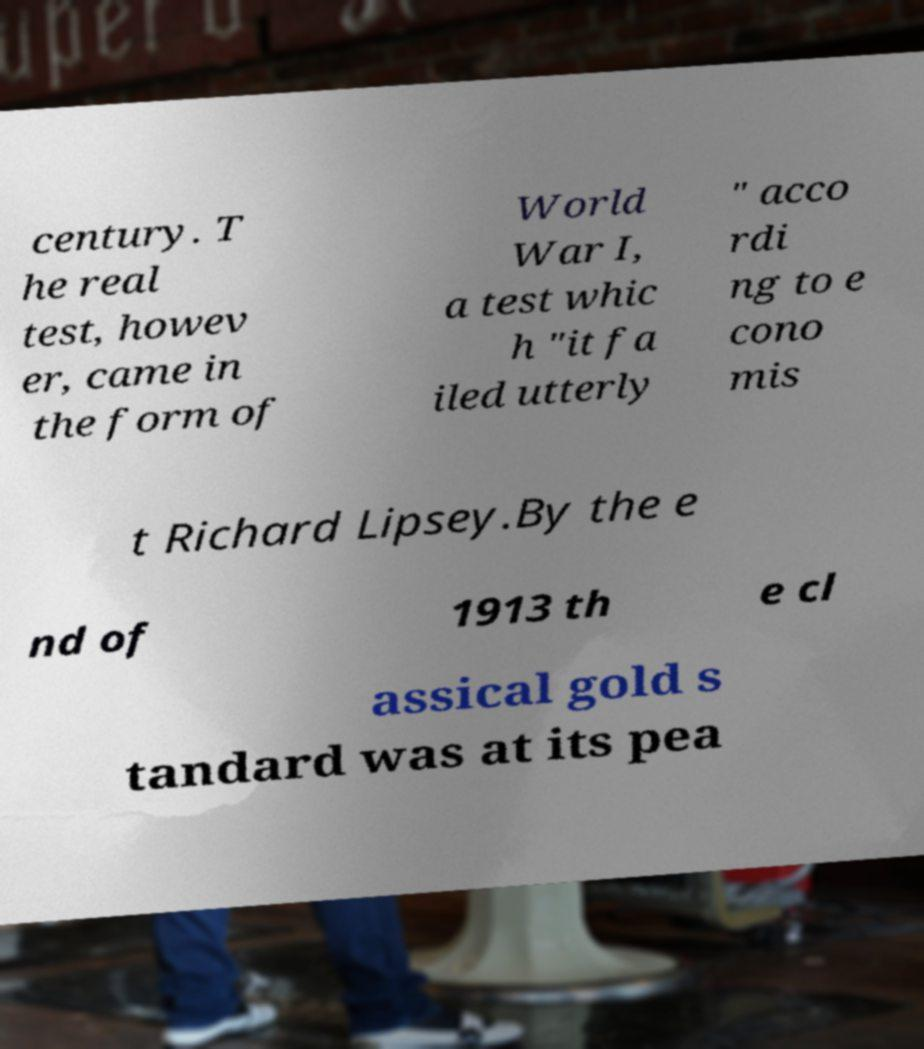Can you read and provide the text displayed in the image?This photo seems to have some interesting text. Can you extract and type it out for me? century. T he real test, howev er, came in the form of World War I, a test whic h "it fa iled utterly " acco rdi ng to e cono mis t Richard Lipsey.By the e nd of 1913 th e cl assical gold s tandard was at its pea 